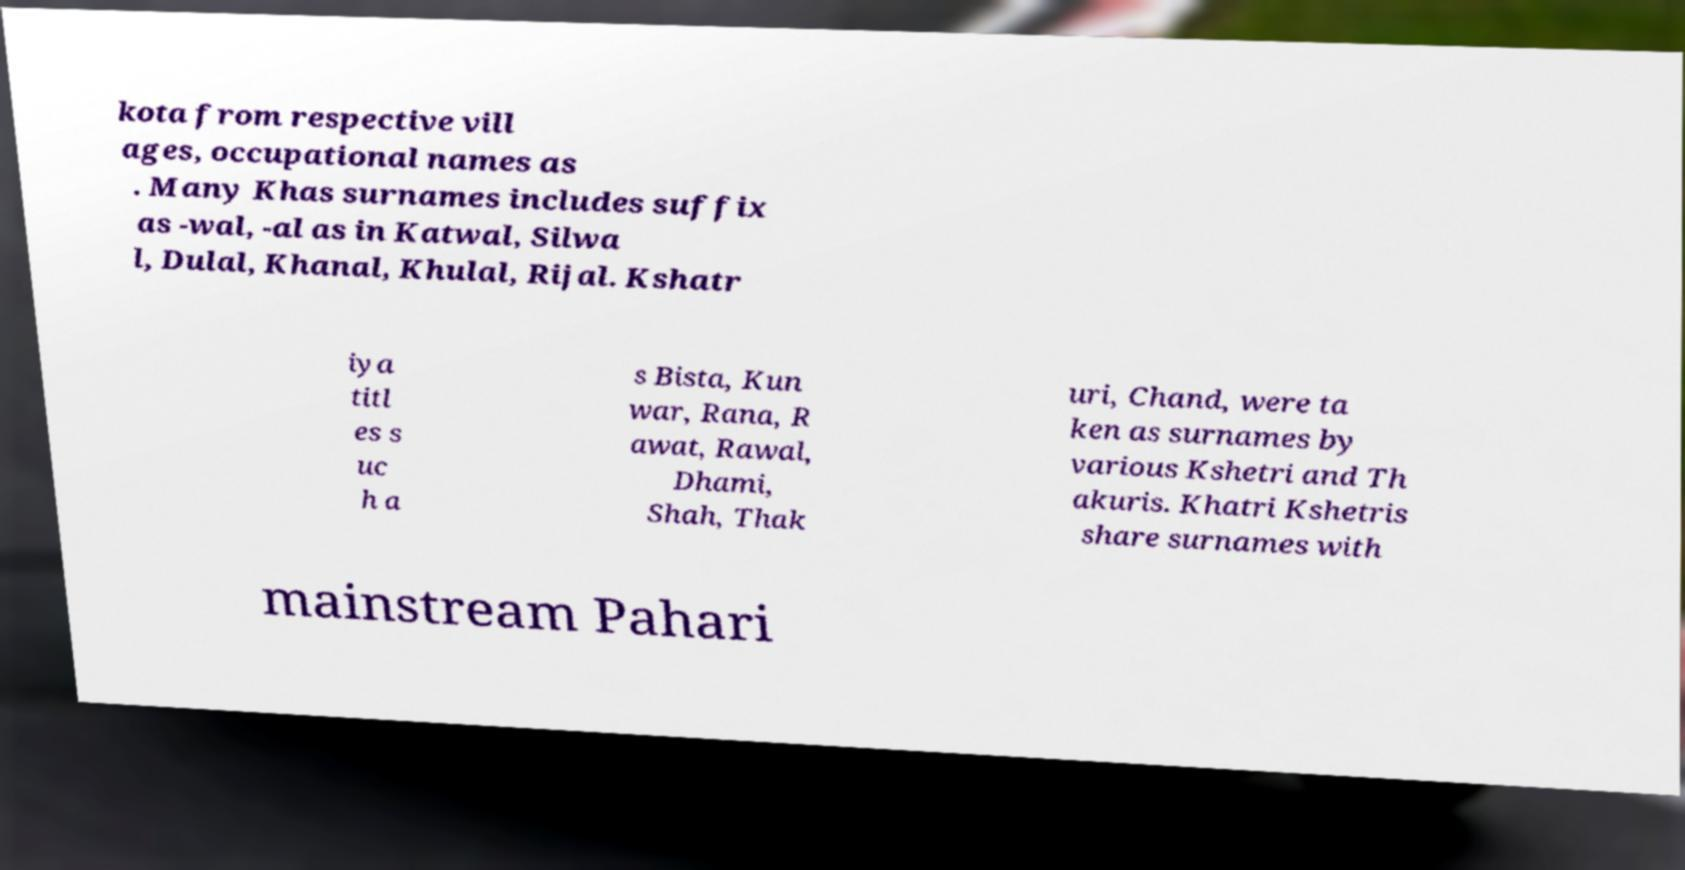Can you accurately transcribe the text from the provided image for me? kota from respective vill ages, occupational names as . Many Khas surnames includes suffix as -wal, -al as in Katwal, Silwa l, Dulal, Khanal, Khulal, Rijal. Kshatr iya titl es s uc h a s Bista, Kun war, Rana, R awat, Rawal, Dhami, Shah, Thak uri, Chand, were ta ken as surnames by various Kshetri and Th akuris. Khatri Kshetris share surnames with mainstream Pahari 